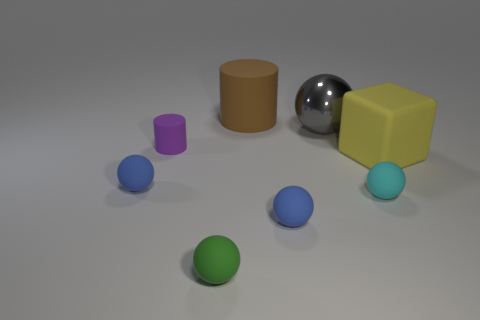Subtract all small spheres. How many spheres are left? 1 Subtract all blue cylinders. How many blue balls are left? 2 Subtract all blue spheres. How many spheres are left? 3 Add 2 blue matte things. How many objects exist? 10 Add 8 yellow things. How many yellow things are left? 9 Add 5 tiny purple matte objects. How many tiny purple matte objects exist? 6 Subtract 1 purple cylinders. How many objects are left? 7 Subtract all spheres. How many objects are left? 3 Subtract 3 balls. How many balls are left? 2 Subtract all brown blocks. Subtract all purple balls. How many blocks are left? 1 